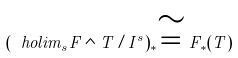Convert formula to latex. <formula><loc_0><loc_0><loc_500><loc_500>( \ h o l i m _ { s } F \wedge T / I ^ { s } ) _ { * } \cong F _ { * } ( T )</formula> 